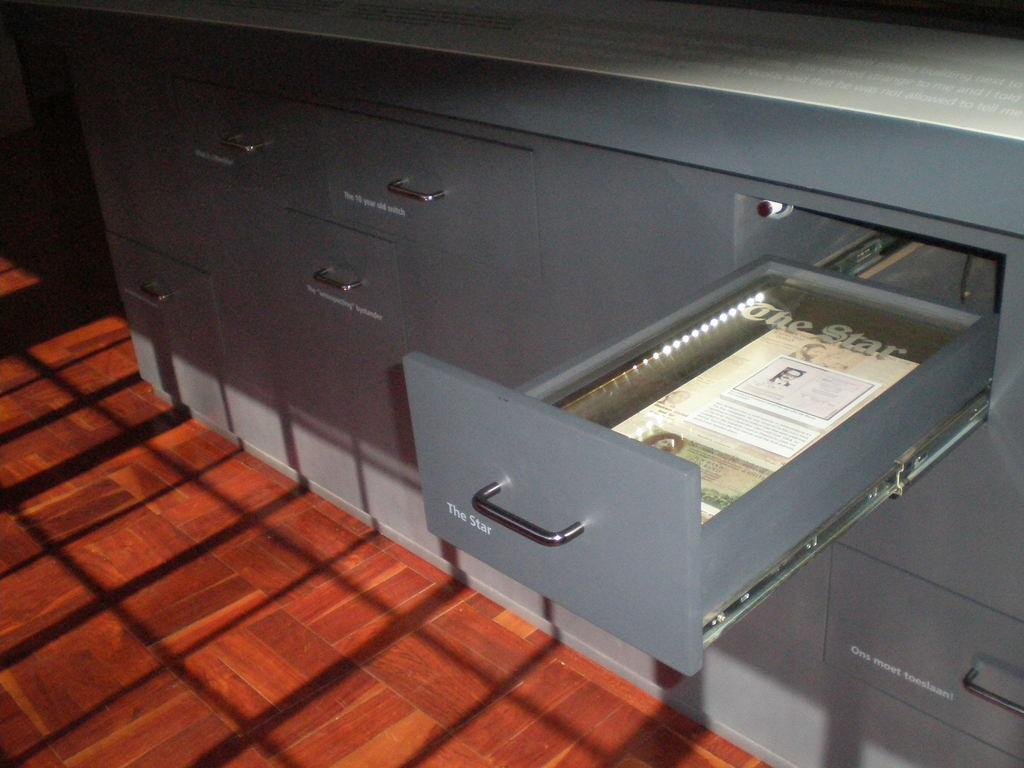What type of furniture is present in the image? There is a table with drawers in the image. Is any of the drawers in the table opened? Yes, one of the drawers is opened. What can be seen inside the opened drawer? Papers are visible inside the opened drawer. How far away is the friend from the table in the image? There is no mention of a friend in the image, so it is not possible to determine the distance between them. 